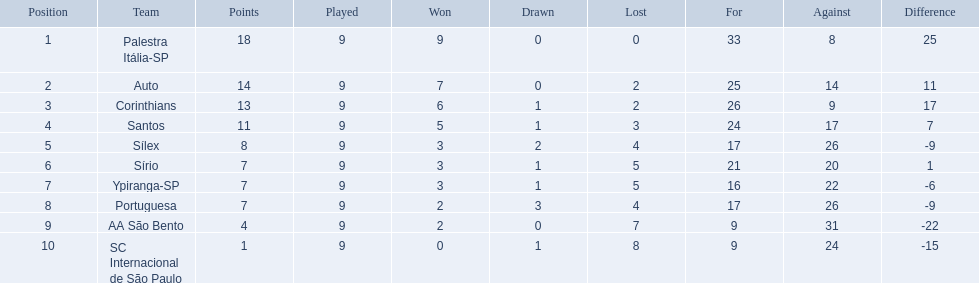Brazilian football in 1926 what teams had no draws? Palestra Itália-SP, Auto, AA São Bento. Of the teams with no draws name the 2 who lost the lease. Palestra Itália-SP, Auto. What team of the 2 who lost the least and had no draws had the highest difference? Palestra Itália-SP. 